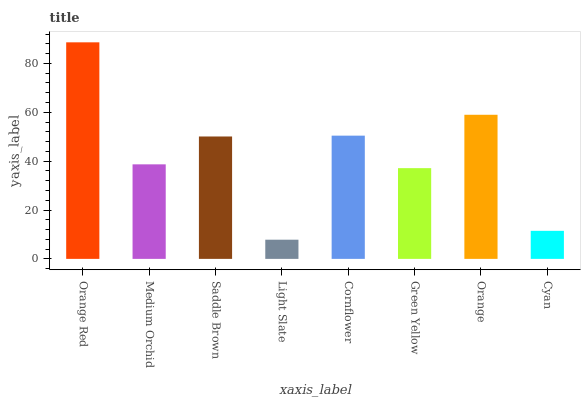Is Light Slate the minimum?
Answer yes or no. Yes. Is Orange Red the maximum?
Answer yes or no. Yes. Is Medium Orchid the minimum?
Answer yes or no. No. Is Medium Orchid the maximum?
Answer yes or no. No. Is Orange Red greater than Medium Orchid?
Answer yes or no. Yes. Is Medium Orchid less than Orange Red?
Answer yes or no. Yes. Is Medium Orchid greater than Orange Red?
Answer yes or no. No. Is Orange Red less than Medium Orchid?
Answer yes or no. No. Is Saddle Brown the high median?
Answer yes or no. Yes. Is Medium Orchid the low median?
Answer yes or no. Yes. Is Orange the high median?
Answer yes or no. No. Is Orange Red the low median?
Answer yes or no. No. 